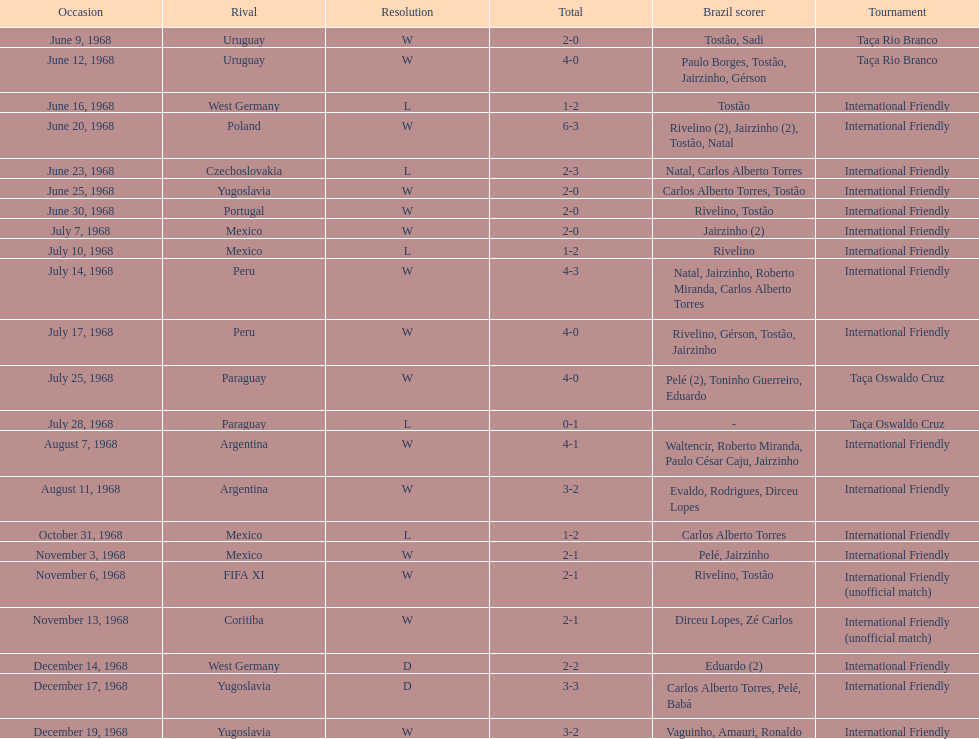Who played brazil previous to the game on june 30th? Yugoslavia. 